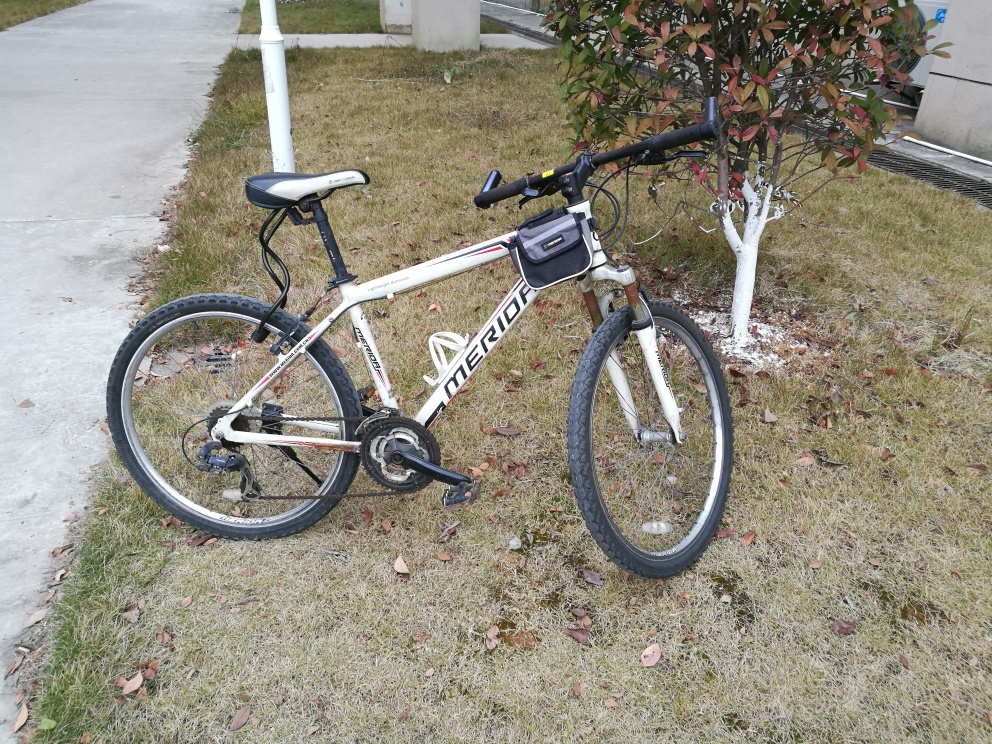What type of bike is shown in the picture? The image shows a mountain bike. You can tell by the frame geometry, the handlebars, and the presence of front suspension, which are typical features of a mountain bike. Is there anything distinctive about the bike's condition or setting? The bike appears to be in a used condition, with some visible wear on the frame and components. It's parked on grass by a concrete path, suggesting it's used for casual riding in a park or similar area. The tree behind the bike has some paint at its base, possibly for protection or marking, which is a common practice in urban or managed green spaces. 